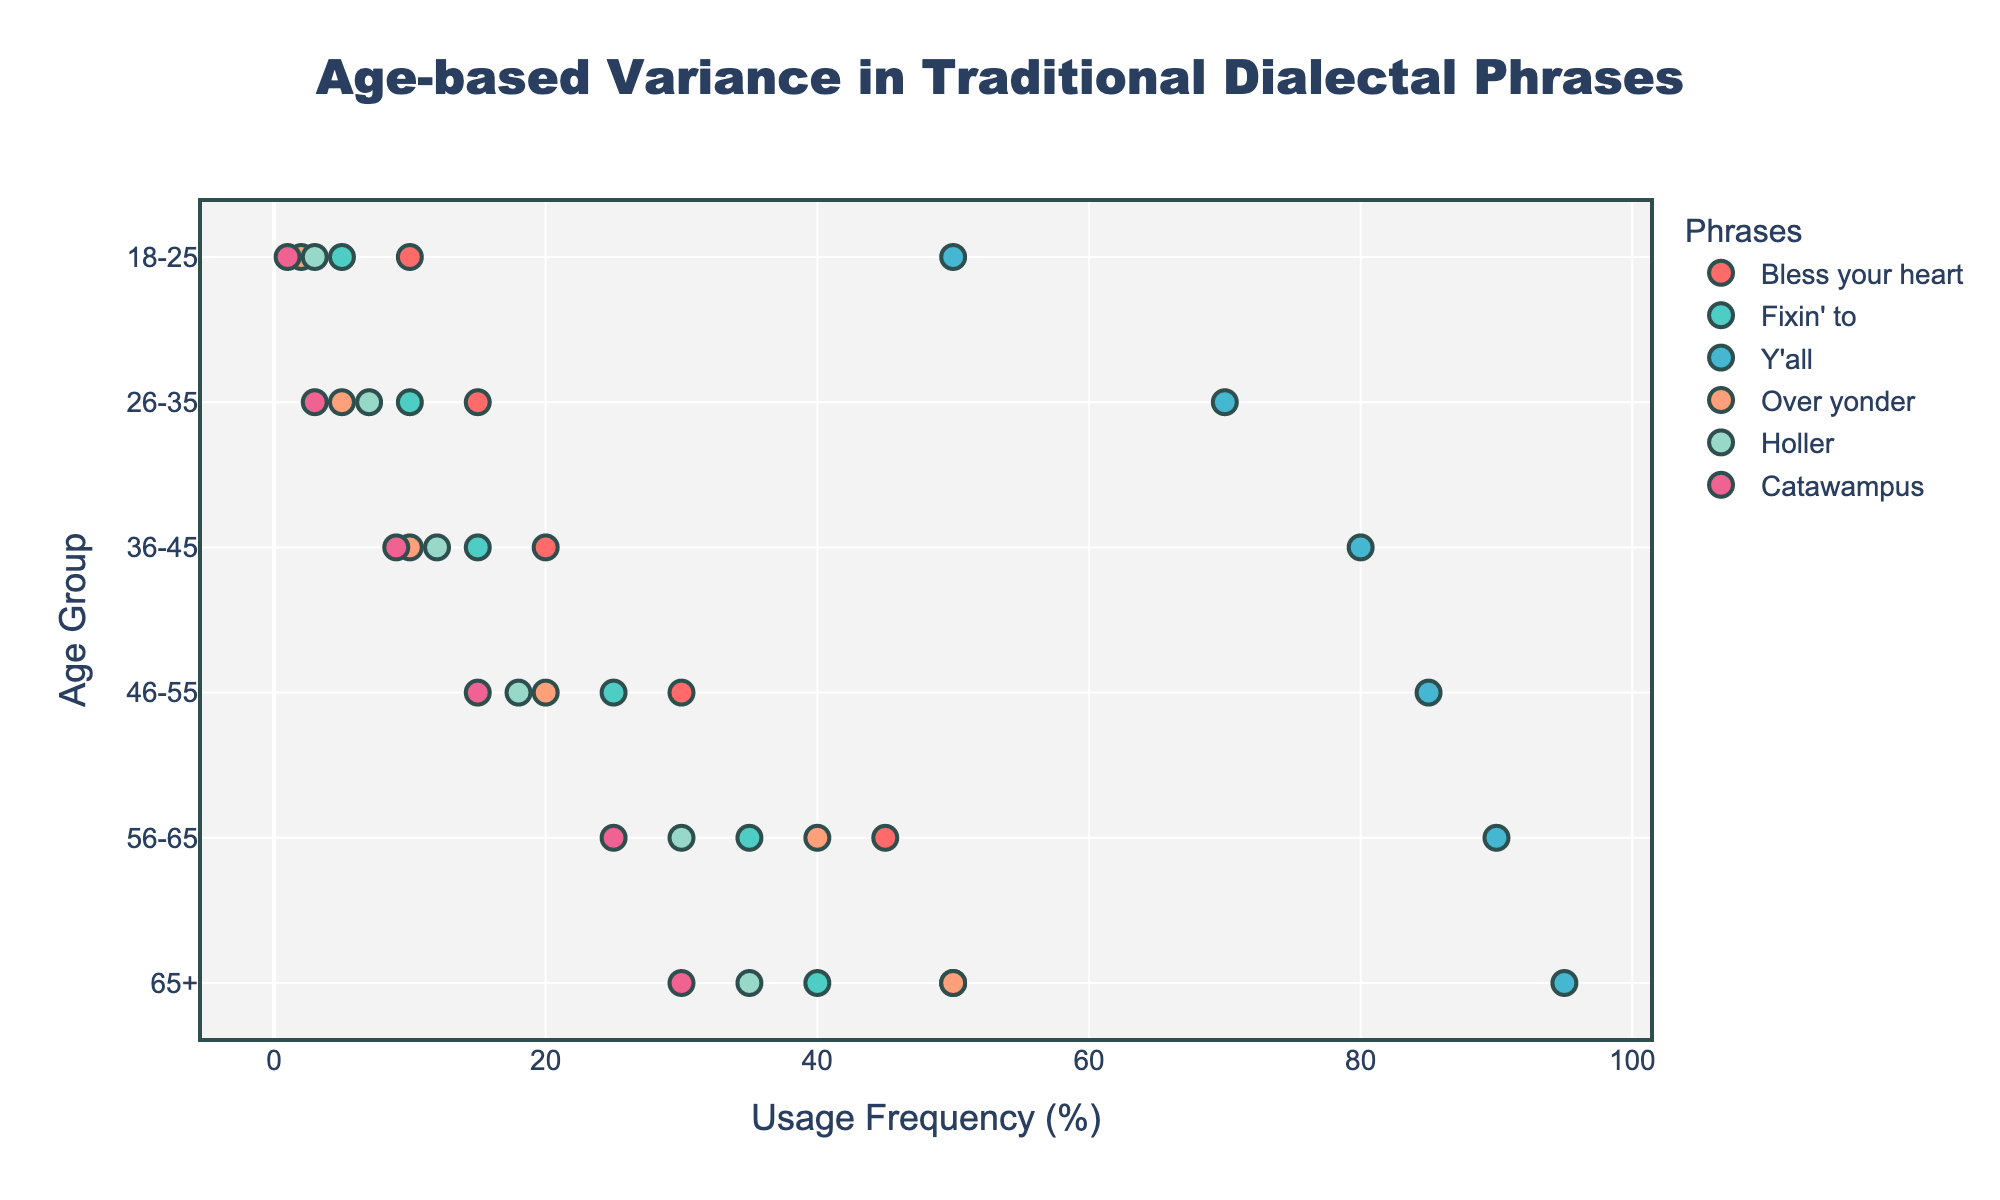What is the title of the figure? The title is shown clearly at the top of the figure and summarizes the main focus. The text in bold and large font reads "Age-based Variance in Traditional Dialectal Phrases."
Answer: Age-based Variance in Traditional Dialectal Phrases Which age group uses the phrase "Fixin' to" most frequently? By observing the y-axis labels (age groups) and the corresponding x-axis values (usage frequency) for the phrase "Fixin' to," the highest frequency data point is in the "65+" age group with a value of 40%.
Answer: 65+ Which phrase is used the least by the "18-25" age group? Looking at the markers plotted for the "18-25" age group, the phrase with the smallest frequency value on the x-axis is "Catawampus," at 1%.
Answer: Catawampus By how much does the frequency of the phrase "Over yonder" increase from the "18-25" age group to the "65+" age group? The frequency for "Over yonder" in the "18-25" age group is 2%, and for the "65+" age group, it is 50%. Subtracting these two values, we get 50% - 2% = 48%.
Answer: 48% Which phrase shows a consistent increase in usage frequency across all age groups? By analyzing the plotted markers for each phrase across all age groups, "Y'all" shows a consistent increase from 50% in the "18-25" group to 95% in the "65+" group without any decline.
Answer: Y'all What is the range of frequency values for the phrase "Holler"? The minimum frequency for "Holler" is 3% in the "18-25" age group, and the maximum is 35% in the "65+" age group. The range is calculated as the difference, 35% - 3% = 32%.
Answer: 32% Compare the usage of the phrase "Bless your heart" between the "46-55" and "56-65" age groups. The frequency for "Bless your heart" in the "46-55" age group is 30%, while in the "56-65" age group it is 45%. There is an increase of 15% from the "46-55" group to the "56-65" group.
Answer: 15% increase For the phrase "Catawampus," what is the incremental increase in frequency from one age group to the next? To find this, calculate the difference in usage frequency between consecutive age groups for "Catawampus": 
  - 18-25 to 26-35: 3% - 1% = 2%
  - 26-35 to 36-45: 9% - 3% = 6%
  - 36-45 to 46-55: 15% - 9% = 6%
  - 46-55 to 56-65: 25% - 15% = 10%
  - 56-65 to 65+: 30% - 25% = 5%
The pattern shows that the incremental increases vary across age groups.
Answer: Varying Which age group has the highest average frequency of using the provided phrases? Calculate the average frequency for each age group:
  - For 18-25: (10% + 5% + 50% + 2% + 3% + 1%) / 6 = 11.83%
  - For 26-35: (15% + 10% + 70% + 5% + 7% + 3%) / 6 = 18.33%
  - For 36-45: (20% + 15% + 80% + 10% + 12% + 9%) / 6 = 24.33%
  - For 46-55: (30% + 25% + 85% + 20% + 18% + 15%) / 6 = 32.17%
  - For 56-65: (45% + 35% + 90% + 40% + 30% + 25%) / 6 = 44.17%
  - For 65+: (50% + 40% + 95% + 50% + 35% + 30%) / 6 = 50%
The "65+" age group has the highest average frequency of 50%.
Answer: 65+ 